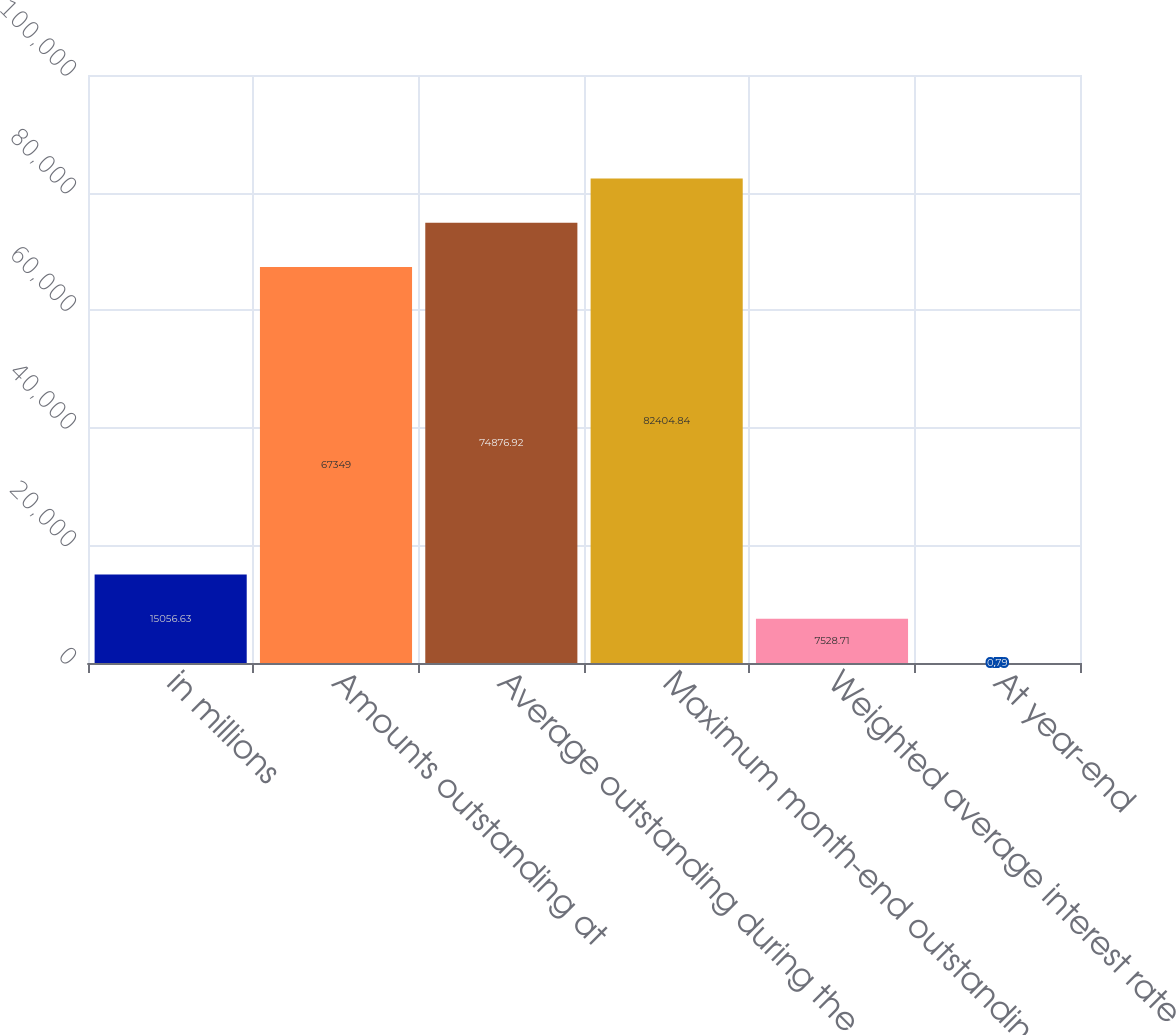<chart> <loc_0><loc_0><loc_500><loc_500><bar_chart><fcel>in millions<fcel>Amounts outstanding at<fcel>Average outstanding during the<fcel>Maximum month-end outstanding<fcel>Weighted average interest rate<fcel>At year-end<nl><fcel>15056.6<fcel>67349<fcel>74876.9<fcel>82404.8<fcel>7528.71<fcel>0.79<nl></chart> 